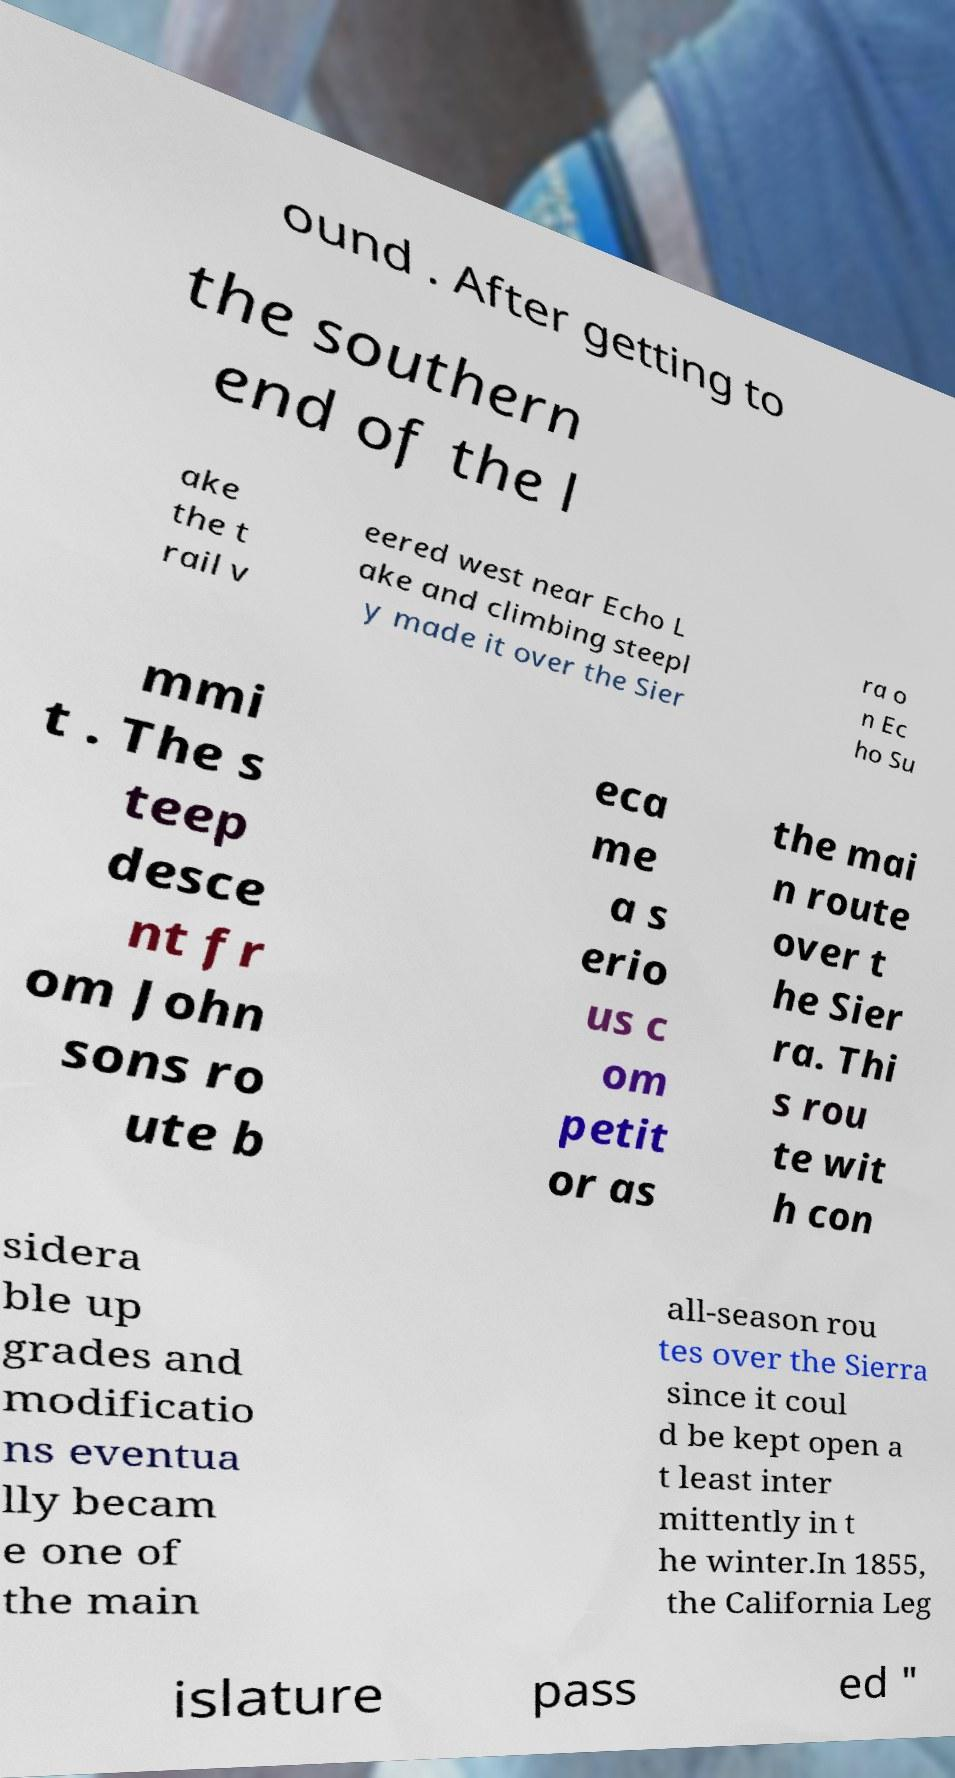Could you assist in decoding the text presented in this image and type it out clearly? ound . After getting to the southern end of the l ake the t rail v eered west near Echo L ake and climbing steepl y made it over the Sier ra o n Ec ho Su mmi t . The s teep desce nt fr om John sons ro ute b eca me a s erio us c om petit or as the mai n route over t he Sier ra. Thi s rou te wit h con sidera ble up grades and modificatio ns eventua lly becam e one of the main all-season rou tes over the Sierra since it coul d be kept open a t least inter mittently in t he winter.In 1855, the California Leg islature pass ed " 